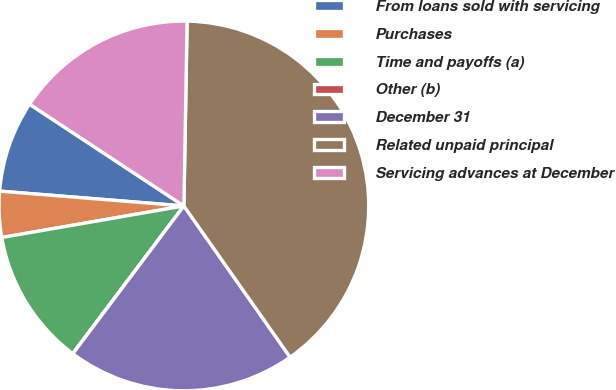Convert chart to OTSL. <chart><loc_0><loc_0><loc_500><loc_500><pie_chart><fcel>From loans sold with servicing<fcel>Purchases<fcel>Time and payoffs (a)<fcel>Other (b)<fcel>December 31<fcel>Related unpaid principal<fcel>Servicing advances at December<nl><fcel>8.0%<fcel>4.01%<fcel>12.0%<fcel>0.01%<fcel>20.0%<fcel>39.98%<fcel>16.0%<nl></chart> 